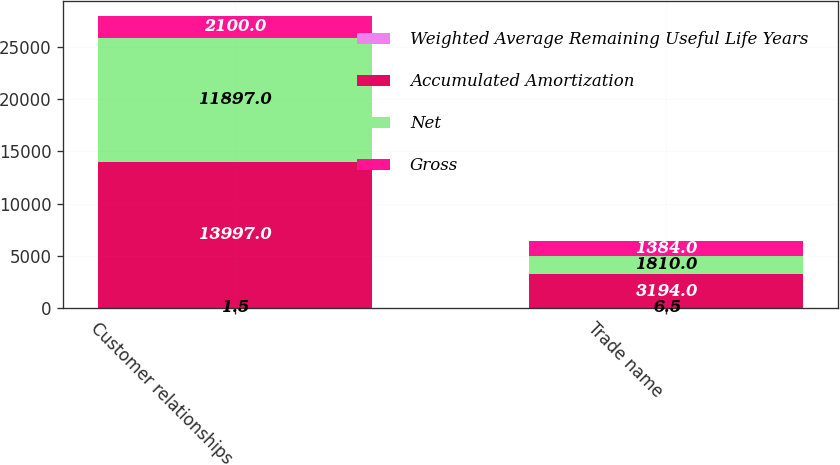Convert chart. <chart><loc_0><loc_0><loc_500><loc_500><stacked_bar_chart><ecel><fcel>Customer relationships<fcel>Trade name<nl><fcel>Weighted Average Remaining Useful Life Years<fcel>1.5<fcel>6.5<nl><fcel>Accumulated Amortization<fcel>13997<fcel>3194<nl><fcel>Net<fcel>11897<fcel>1810<nl><fcel>Gross<fcel>2100<fcel>1384<nl></chart> 